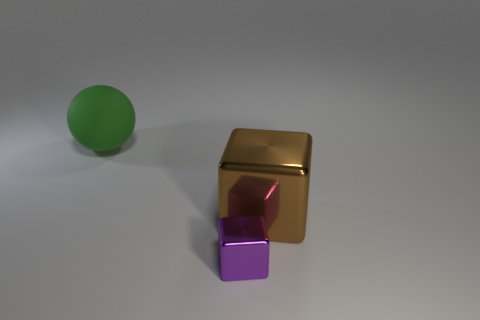How many other things are there of the same color as the big ball?
Keep it short and to the point. 0. Are any small gray metallic cubes visible?
Offer a very short reply. No. There is a thing behind the object that is right of the purple cube; how big is it?
Offer a very short reply. Large. Is the number of blocks in front of the large metal block greater than the number of large brown shiny cubes that are to the left of the purple metallic thing?
Ensure brevity in your answer.  Yes. How many spheres are either large yellow objects or large green objects?
Make the answer very short. 1. Is there any other thing that is the same size as the purple object?
Keep it short and to the point. No. Is the shape of the large thing right of the matte object the same as  the large green thing?
Ensure brevity in your answer.  No. What color is the ball?
Give a very brief answer. Green. What is the color of the other metal thing that is the same shape as the tiny thing?
Provide a succinct answer. Brown. How many other metal things are the same shape as the small purple metallic thing?
Your answer should be compact. 1. 